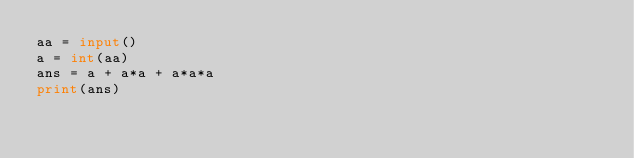Convert code to text. <code><loc_0><loc_0><loc_500><loc_500><_Python_>aa = input()
a = int(aa)
ans = a + a*a + a*a*a
print(ans)</code> 